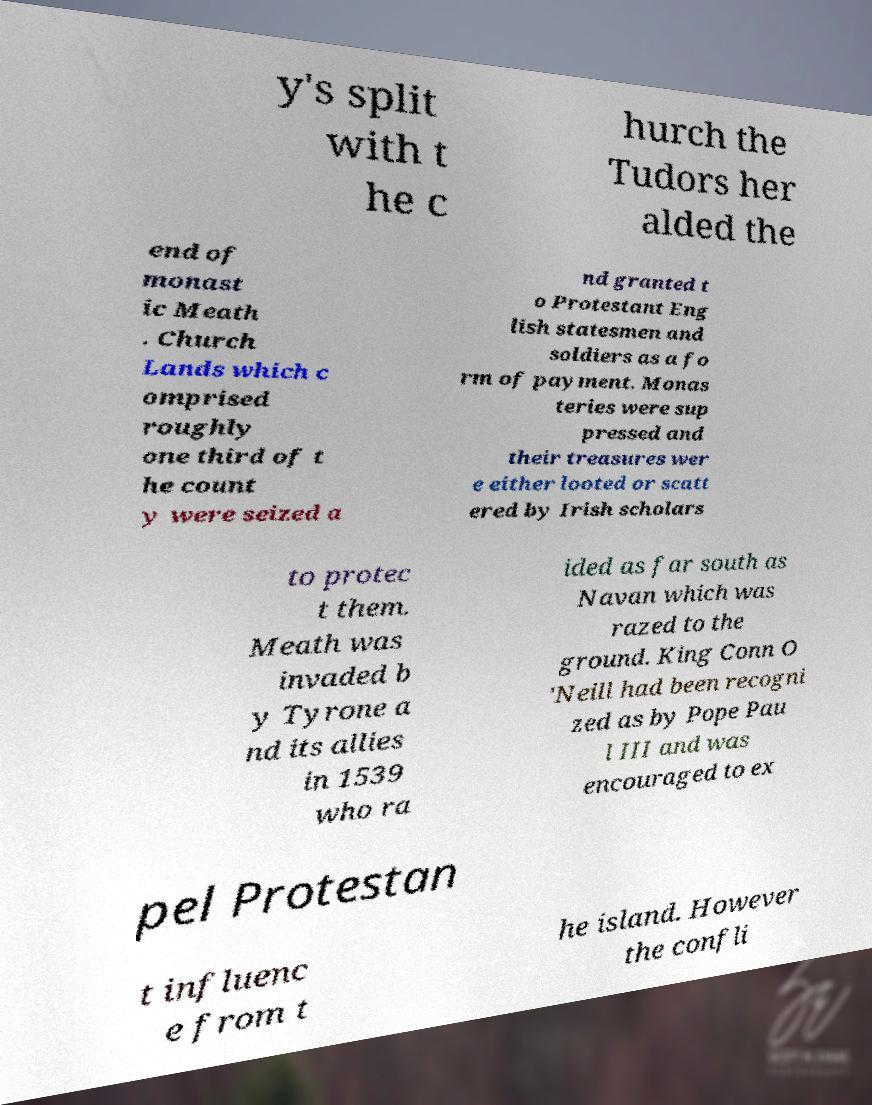There's text embedded in this image that I need extracted. Can you transcribe it verbatim? y's split with t he c hurch the Tudors her alded the end of monast ic Meath . Church Lands which c omprised roughly one third of t he count y were seized a nd granted t o Protestant Eng lish statesmen and soldiers as a fo rm of payment. Monas teries were sup pressed and their treasures wer e either looted or scatt ered by Irish scholars to protec t them. Meath was invaded b y Tyrone a nd its allies in 1539 who ra ided as far south as Navan which was razed to the ground. King Conn O 'Neill had been recogni zed as by Pope Pau l III and was encouraged to ex pel Protestan t influenc e from t he island. However the confli 